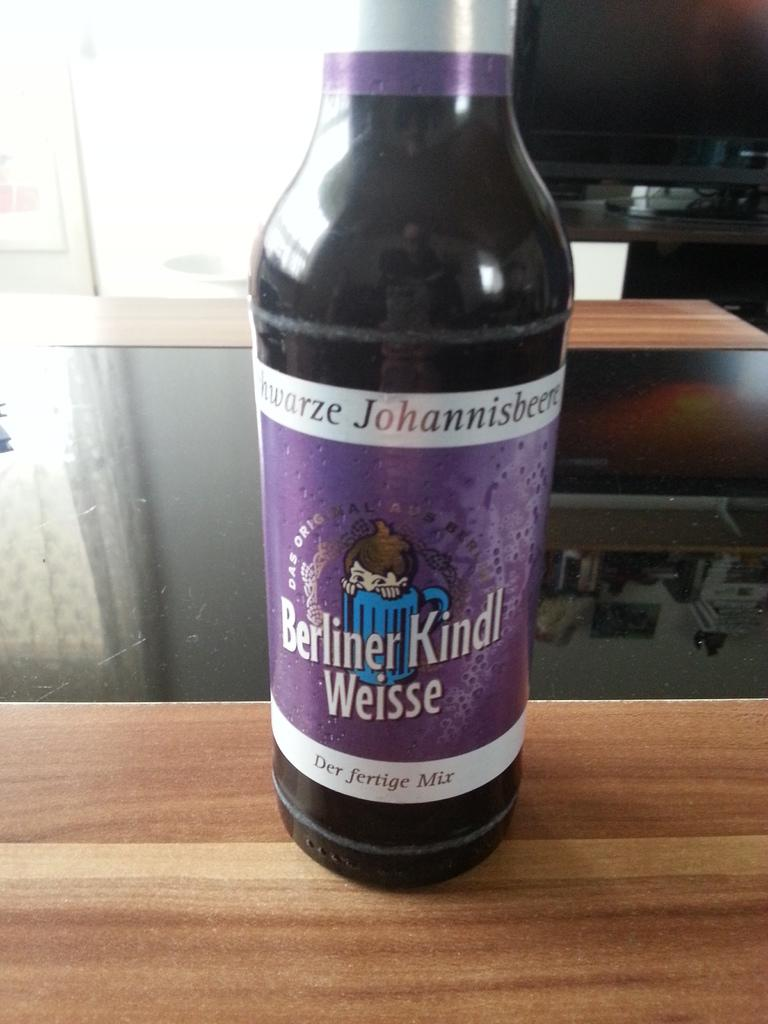<image>
Describe the image concisely. Purple bottle of drink with the name, Berliner Kindl Weisse on the label. 